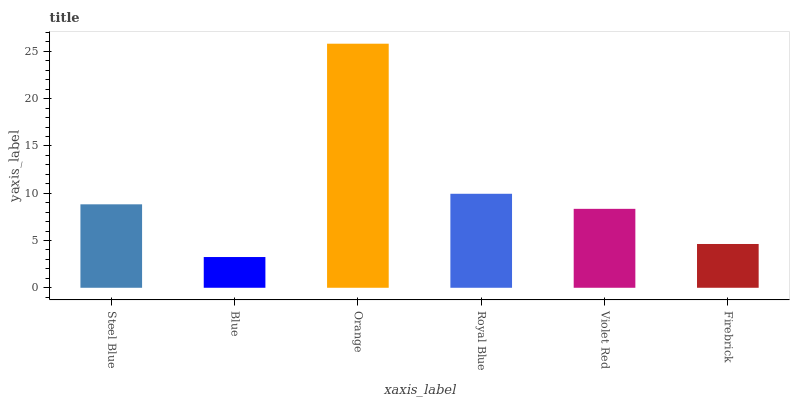Is Blue the minimum?
Answer yes or no. Yes. Is Orange the maximum?
Answer yes or no. Yes. Is Orange the minimum?
Answer yes or no. No. Is Blue the maximum?
Answer yes or no. No. Is Orange greater than Blue?
Answer yes or no. Yes. Is Blue less than Orange?
Answer yes or no. Yes. Is Blue greater than Orange?
Answer yes or no. No. Is Orange less than Blue?
Answer yes or no. No. Is Steel Blue the high median?
Answer yes or no. Yes. Is Violet Red the low median?
Answer yes or no. Yes. Is Blue the high median?
Answer yes or no. No. Is Royal Blue the low median?
Answer yes or no. No. 